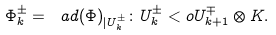<formula> <loc_0><loc_0><loc_500><loc_500>\Phi _ { k } ^ { \pm } = \ a d ( \Phi ) _ { | U _ { k } ^ { \pm } } \colon U _ { k } ^ { \pm } < o U _ { k + 1 } ^ { \mp } \otimes K .</formula> 